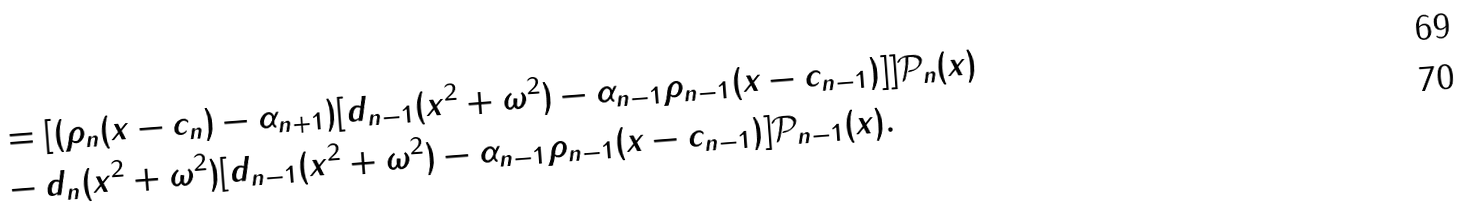<formula> <loc_0><loc_0><loc_500><loc_500>& = [ ( \rho _ { n } ( x - c _ { n } ) - \alpha _ { n + 1 } ) [ d _ { n - 1 } ( x ^ { 2 } + \omega ^ { 2 } ) - \alpha _ { n - 1 } \rho _ { n - 1 } ( x - c _ { n - 1 } ) ] ] \mathcal { P } _ { n } ( x ) \\ & - d _ { n } ( x ^ { 2 } + \omega ^ { 2 } ) [ d _ { n - 1 } ( x ^ { 2 } + \omega ^ { 2 } ) - \alpha _ { n - 1 } \rho _ { n - 1 } ( x - c _ { n - 1 } ) ] \mathcal { P } _ { n - 1 } ( x ) .</formula> 